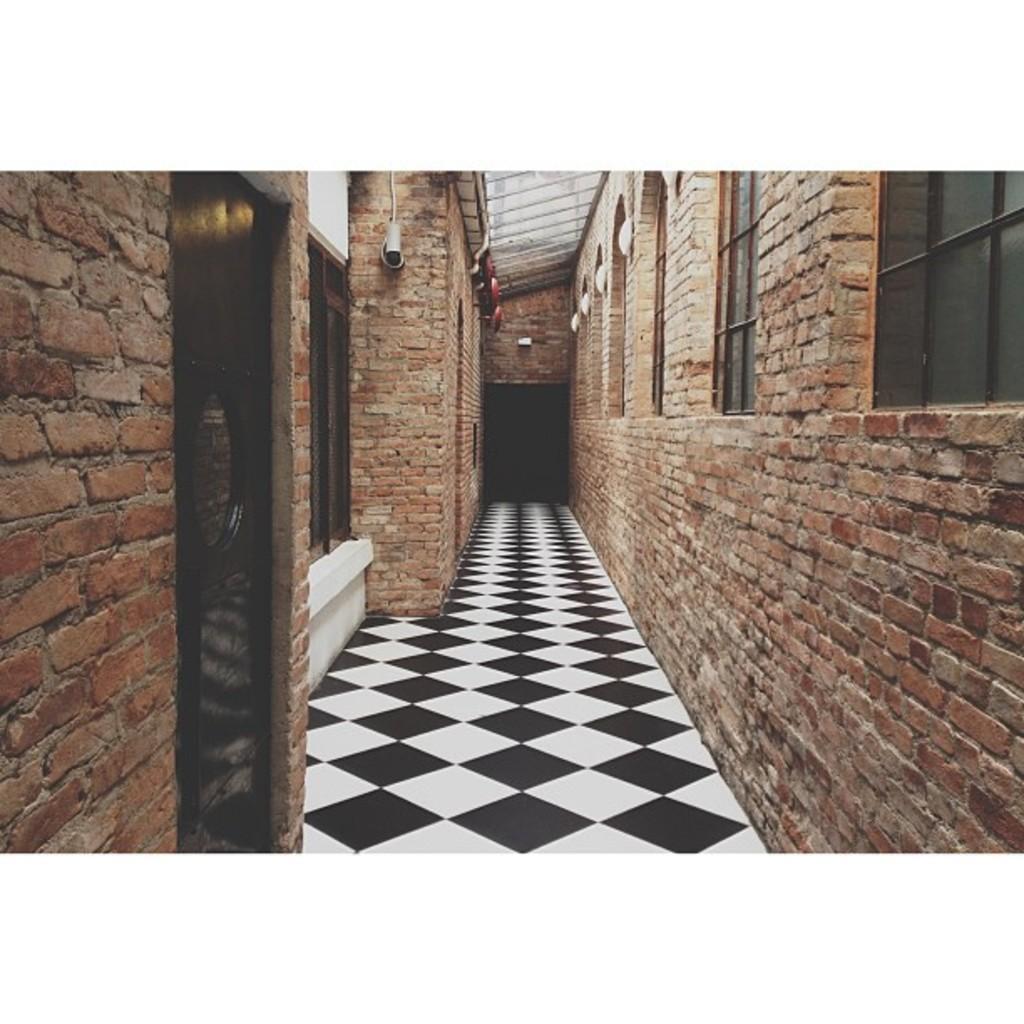Describe this image in one or two sentences. In this image I can see building walls of bricks, door, windows and a rooftop. This image is taken may be in a building. 